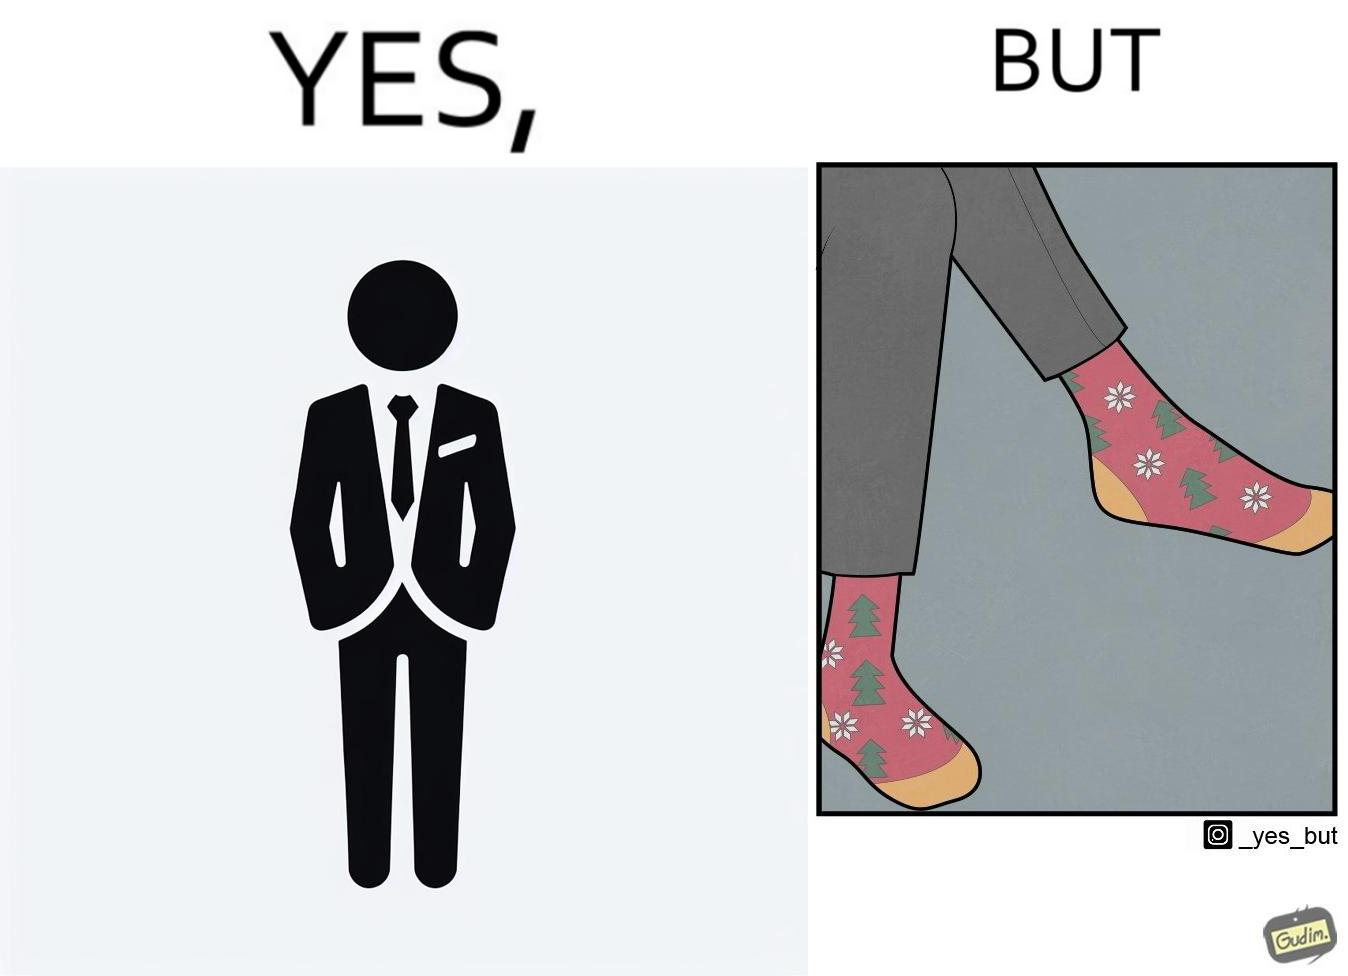Compare the left and right sides of this image. In the left part of the image: A person in black formal suit and pants In the right part of the image: Legs of a person with black pants, and colorful socks with flowers and trees drawn on it. 